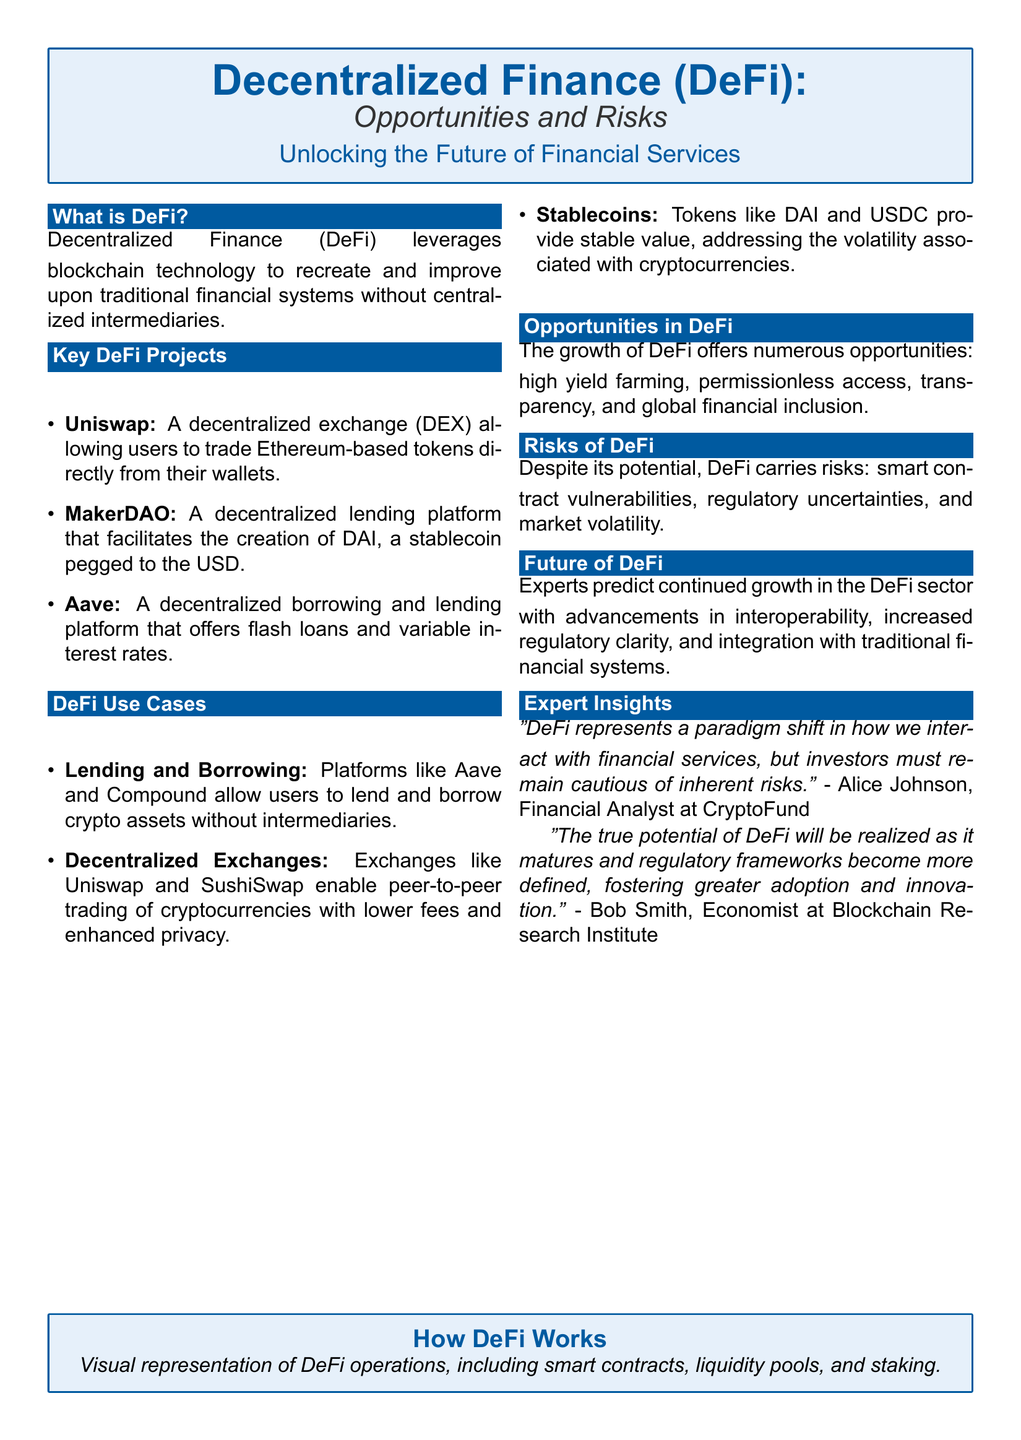What is DeFi? DeFi is defined as a financial system leveraging blockchain technology without centralized intermediaries.
Answer: A financial system leveraging blockchain technology without centralized intermediaries What is Uniswap? Uniswap is identified as a decentralized exchange (DEX) that facilitates trading Ethereum-based tokens.
Answer: A decentralized exchange (DEX) What does Aave offer? Aave is described as offering decentralized borrowing and lending, including flash loans and variable interest rates.
Answer: Decentralized borrowing and lending What is the role of stablecoins in DeFi? The document states that stablecoins like DAI address the volatility associated with cryptocurrencies by providing stable value.
Answer: Addressing volatility with stable value What are the main risks of DeFi? The risks listed include smart contract vulnerabilities, regulatory uncertainties, and market volatility.
Answer: Smart contract vulnerabilities, regulatory uncertainties, and market volatility What opportunities does DeFi provide? DeFi offers high yield farming, permissionless access, transparency, and global financial inclusion as opportunities.
Answer: High yield farming, permissionless access, transparency, and global financial inclusion Who is Alice Johnson? Alice Johnson is referenced as a Financial Analyst at CryptoFund providing insights on DeFi risks.
Answer: Financial Analyst at CryptoFund What future trend is predicted for DeFi? Experts predict that DeFi will continue to grow with advancements in interoperability and increased regulatory clarity.
Answer: Continued growth with interoperability advancements What is the color scheme of the document? The document describes a color scheme that includes main blue and light blue for design elements.
Answer: Main blue and light blue 